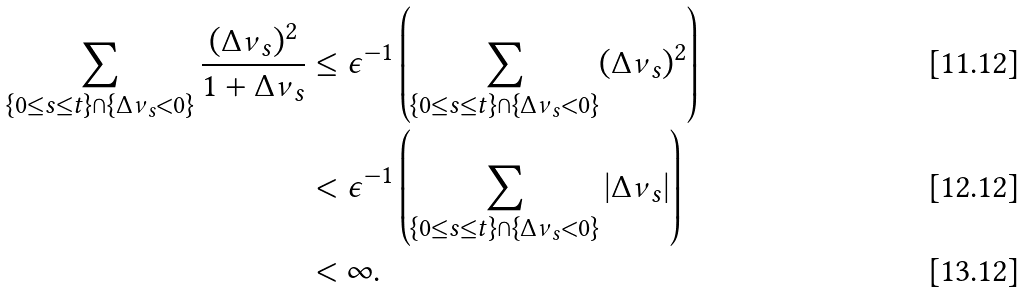<formula> <loc_0><loc_0><loc_500><loc_500>\sum _ { \{ 0 \leq s \leq t \} \cap \{ \Delta \nu _ { s } < 0 \} } \frac { ( \Delta \nu _ { s } ) ^ { 2 } } { 1 + \Delta \nu _ { s } } & \leq \epsilon ^ { - 1 } \left ( \sum _ { \{ 0 \leq s \leq t \} \cap \{ \Delta \nu _ { s } < 0 \} } ( \Delta \nu _ { s } ) ^ { 2 } \right ) \\ & < \epsilon ^ { - 1 } \left ( \sum _ { \{ 0 \leq s \leq t \} \cap \{ \Delta \nu _ { s } < 0 \} } | \Delta \nu _ { s } | \right ) \\ & < \infty .</formula> 